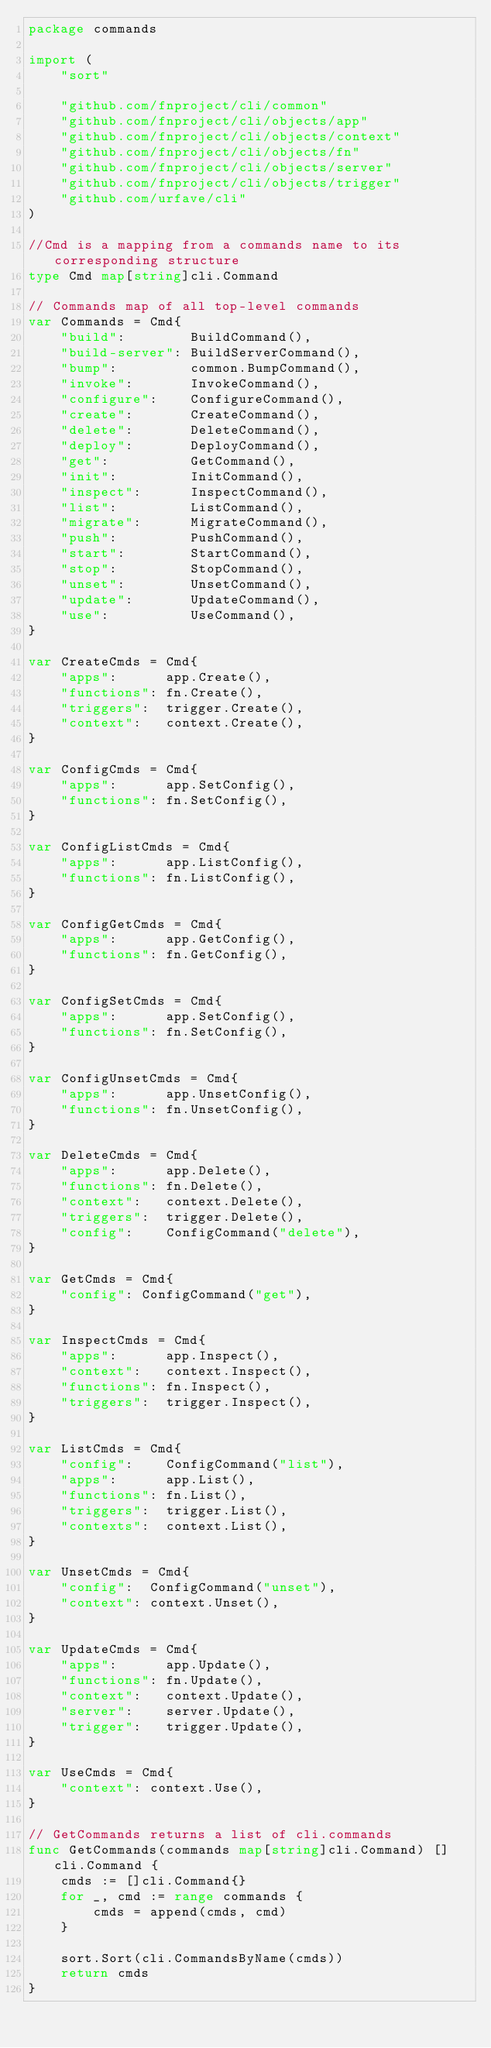Convert code to text. <code><loc_0><loc_0><loc_500><loc_500><_Go_>package commands

import (
	"sort"

	"github.com/fnproject/cli/common"
	"github.com/fnproject/cli/objects/app"
	"github.com/fnproject/cli/objects/context"
	"github.com/fnproject/cli/objects/fn"
	"github.com/fnproject/cli/objects/server"
	"github.com/fnproject/cli/objects/trigger"
	"github.com/urfave/cli"
)

//Cmd is a mapping from a commands name to its corresponding structure
type Cmd map[string]cli.Command

// Commands map of all top-level commands
var Commands = Cmd{
	"build":        BuildCommand(),
	"build-server": BuildServerCommand(),
	"bump":         common.BumpCommand(),
	"invoke":       InvokeCommand(),
	"configure":    ConfigureCommand(),
	"create":       CreateCommand(),
	"delete":       DeleteCommand(),
	"deploy":       DeployCommand(),
	"get":          GetCommand(),
	"init":         InitCommand(),
	"inspect":      InspectCommand(),
	"list":         ListCommand(),
	"migrate":      MigrateCommand(),
	"push":         PushCommand(),
	"start":        StartCommand(),
	"stop":         StopCommand(),
	"unset":        UnsetCommand(),
	"update":       UpdateCommand(),
	"use":          UseCommand(),
}

var CreateCmds = Cmd{
	"apps":      app.Create(),
	"functions": fn.Create(),
	"triggers":  trigger.Create(),
	"context":   context.Create(),
}

var ConfigCmds = Cmd{
	"apps":      app.SetConfig(),
	"functions": fn.SetConfig(),
}

var ConfigListCmds = Cmd{
	"apps":      app.ListConfig(),
	"functions": fn.ListConfig(),
}

var ConfigGetCmds = Cmd{
	"apps":      app.GetConfig(),
	"functions": fn.GetConfig(),
}

var ConfigSetCmds = Cmd{
	"apps":      app.SetConfig(),
	"functions": fn.SetConfig(),
}

var ConfigUnsetCmds = Cmd{
	"apps":      app.UnsetConfig(),
	"functions": fn.UnsetConfig(),
}

var DeleteCmds = Cmd{
	"apps":      app.Delete(),
	"functions": fn.Delete(),
	"context":   context.Delete(),
	"triggers":  trigger.Delete(),
	"config":    ConfigCommand("delete"),
}

var GetCmds = Cmd{
	"config": ConfigCommand("get"),
}

var InspectCmds = Cmd{
	"apps":      app.Inspect(),
	"context":   context.Inspect(),
	"functions": fn.Inspect(),
	"triggers":  trigger.Inspect(),
}

var ListCmds = Cmd{
	"config":    ConfigCommand("list"),
	"apps":      app.List(),
	"functions": fn.List(),
	"triggers":  trigger.List(),
	"contexts":  context.List(),
}

var UnsetCmds = Cmd{
	"config":  ConfigCommand("unset"),
	"context": context.Unset(),
}

var UpdateCmds = Cmd{
	"apps":      app.Update(),
	"functions": fn.Update(),
	"context":   context.Update(),
	"server":    server.Update(),
	"trigger":   trigger.Update(),
}

var UseCmds = Cmd{
	"context": context.Use(),
}

// GetCommands returns a list of cli.commands
func GetCommands(commands map[string]cli.Command) []cli.Command {
	cmds := []cli.Command{}
	for _, cmd := range commands {
		cmds = append(cmds, cmd)
	}

	sort.Sort(cli.CommandsByName(cmds))
	return cmds
}
</code> 